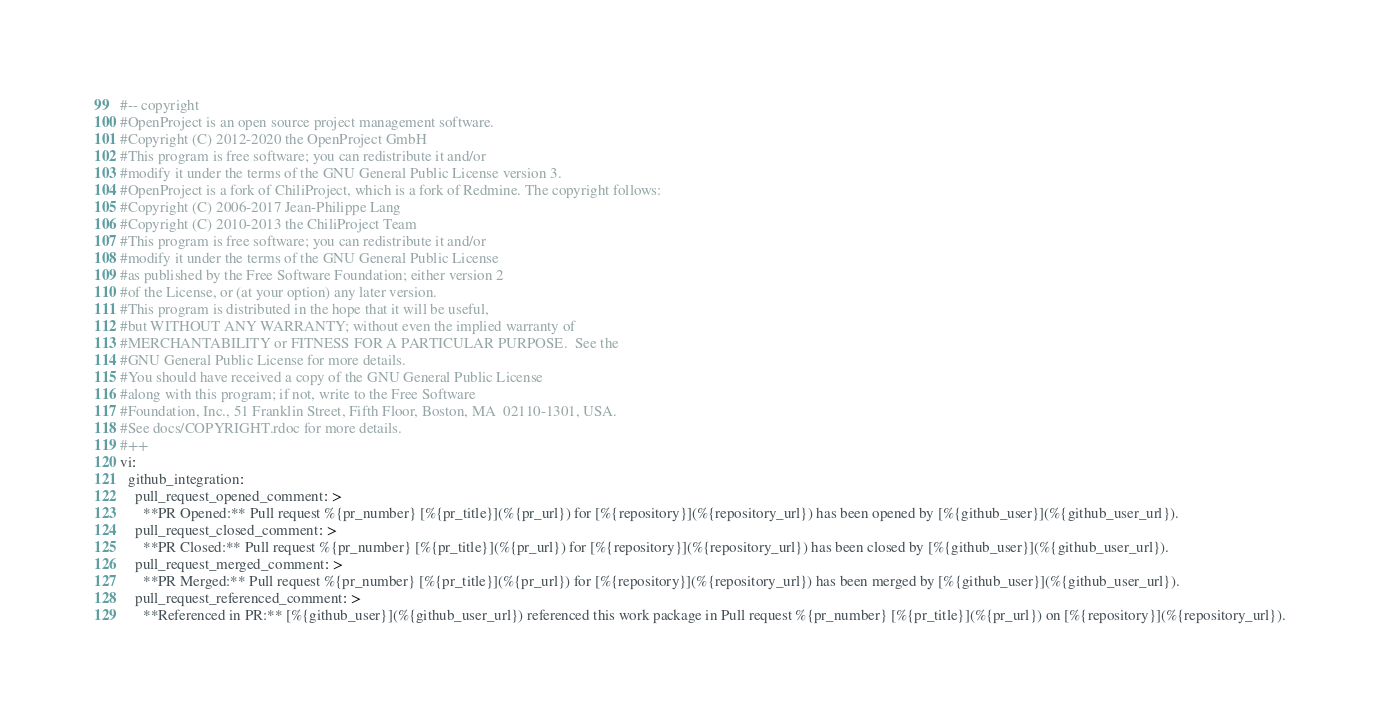Convert code to text. <code><loc_0><loc_0><loc_500><loc_500><_YAML_>#-- copyright
#OpenProject is an open source project management software.
#Copyright (C) 2012-2020 the OpenProject GmbH
#This program is free software; you can redistribute it and/or
#modify it under the terms of the GNU General Public License version 3.
#OpenProject is a fork of ChiliProject, which is a fork of Redmine. The copyright follows:
#Copyright (C) 2006-2017 Jean-Philippe Lang
#Copyright (C) 2010-2013 the ChiliProject Team
#This program is free software; you can redistribute it and/or
#modify it under the terms of the GNU General Public License
#as published by the Free Software Foundation; either version 2
#of the License, or (at your option) any later version.
#This program is distributed in the hope that it will be useful,
#but WITHOUT ANY WARRANTY; without even the implied warranty of
#MERCHANTABILITY or FITNESS FOR A PARTICULAR PURPOSE.  See the
#GNU General Public License for more details.
#You should have received a copy of the GNU General Public License
#along with this program; if not, write to the Free Software
#Foundation, Inc., 51 Franklin Street, Fifth Floor, Boston, MA  02110-1301, USA.
#See docs/COPYRIGHT.rdoc for more details.
#++
vi:
  github_integration:
    pull_request_opened_comment: >
      **PR Opened:** Pull request %{pr_number} [%{pr_title}](%{pr_url}) for [%{repository}](%{repository_url}) has been opened by [%{github_user}](%{github_user_url}).
    pull_request_closed_comment: >
      **PR Closed:** Pull request %{pr_number} [%{pr_title}](%{pr_url}) for [%{repository}](%{repository_url}) has been closed by [%{github_user}](%{github_user_url}).
    pull_request_merged_comment: >
      **PR Merged:** Pull request %{pr_number} [%{pr_title}](%{pr_url}) for [%{repository}](%{repository_url}) has been merged by [%{github_user}](%{github_user_url}).
    pull_request_referenced_comment: >
      **Referenced in PR:** [%{github_user}](%{github_user_url}) referenced this work package in Pull request %{pr_number} [%{pr_title}](%{pr_url}) on [%{repository}](%{repository_url}).
</code> 